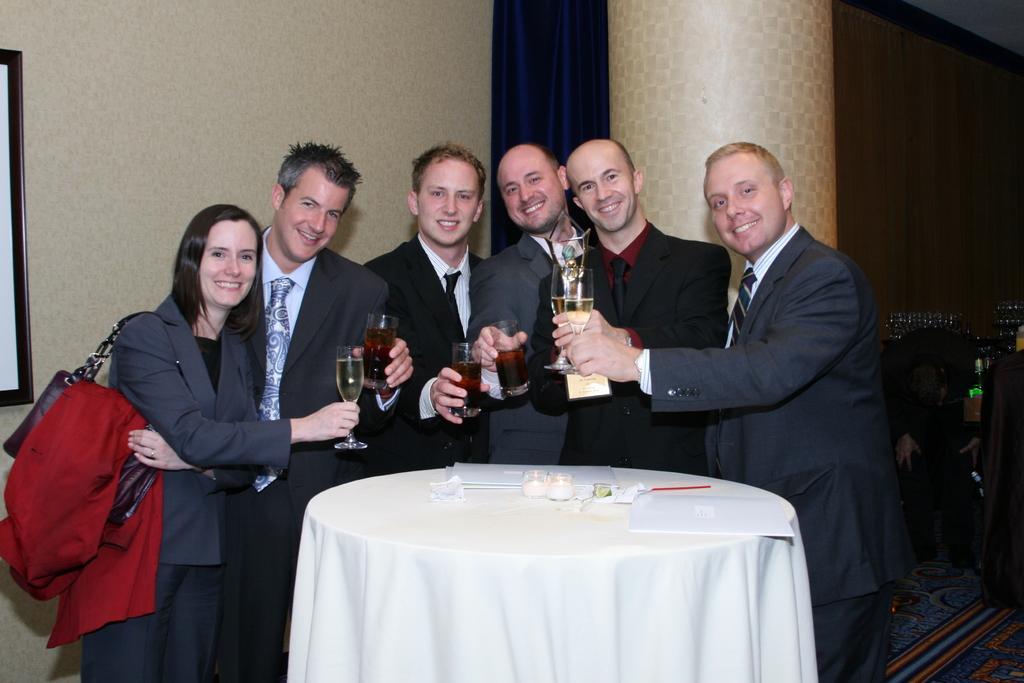Could you give a brief overview of what you see in this image? In the image we can see there are people who are standing and they are holding wine glasses in their hand. 